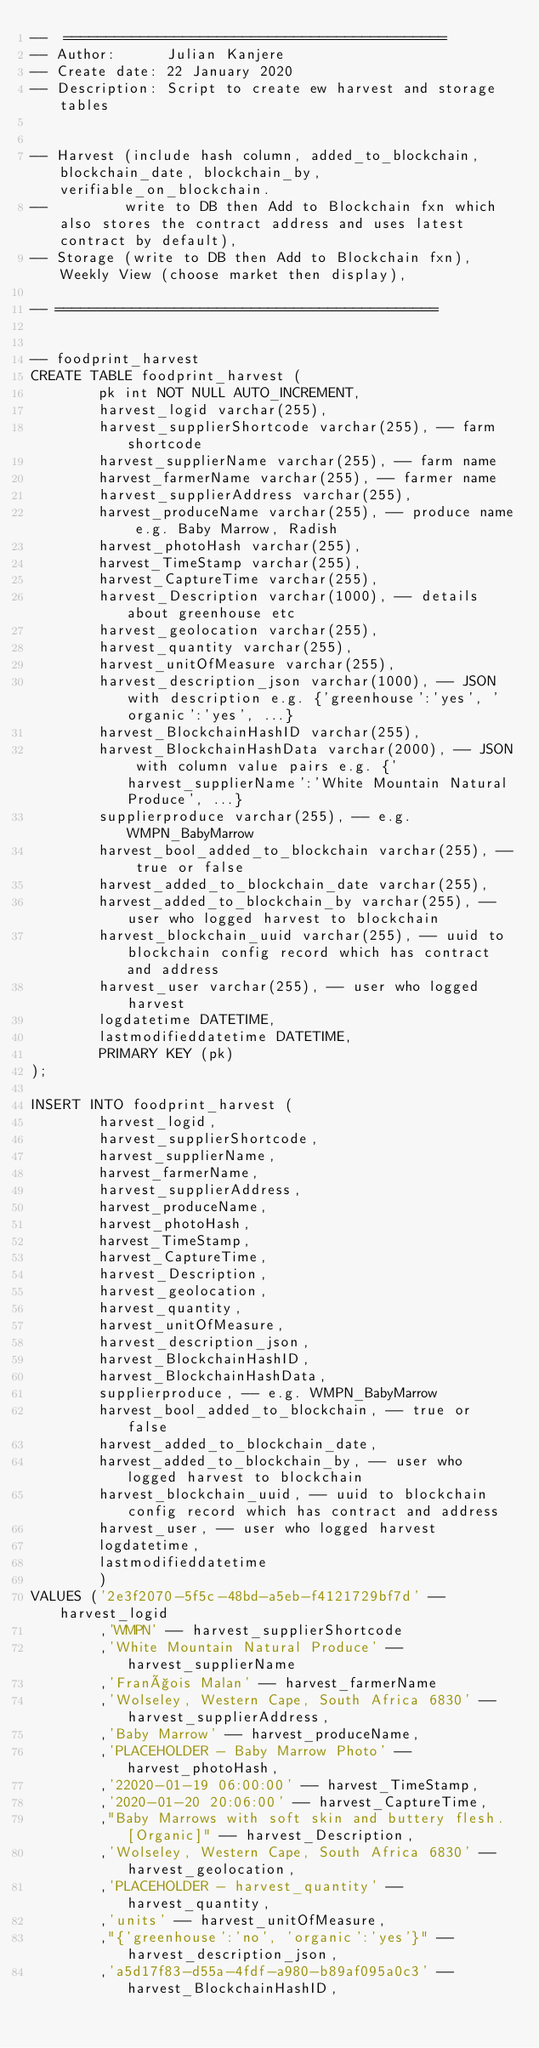<code> <loc_0><loc_0><loc_500><loc_500><_SQL_>--  =============================================
-- Author:      Julian Kanjere
-- Create date: 22 January 2020
-- Description: Script to create ew harvest and storage tables


-- Harvest (include hash column, added_to_blockchain, blockchain_date, blockchain_by, verifiable_on_blockchain.
--         write to DB then Add to Blockchain fxn which also stores the contract address and uses latest contract by default),
-- Storage (write to DB then Add to Blockchain fxn), Weekly View (choose market then display),

-- =============================================


-- foodprint_harvest
CREATE TABLE foodprint_harvest (
        pk int NOT NULL AUTO_INCREMENT,
        harvest_logid varchar(255),
        harvest_supplierShortcode varchar(255), -- farm shortcode
        harvest_supplierName varchar(255), -- farm name
        harvest_farmerName varchar(255), -- farmer name
        harvest_supplierAddress varchar(255),
        harvest_produceName varchar(255), -- produce name e.g. Baby Marrow, Radish
        harvest_photoHash varchar(255),
        harvest_TimeStamp varchar(255),
        harvest_CaptureTime varchar(255),
        harvest_Description varchar(1000), -- details about greenhouse etc
        harvest_geolocation varchar(255),
        harvest_quantity varchar(255),
        harvest_unitOfMeasure varchar(255),
        harvest_description_json varchar(1000), -- JSON with description e.g. {'greenhouse':'yes', 'organic':'yes', ...}
        harvest_BlockchainHashID varchar(255),
        harvest_BlockchainHashData varchar(2000), -- JSON with column value pairs e.g. {'harvest_supplierName':'White Mountain Natural Produce', ...}
        supplierproduce varchar(255), -- e.g. WMPN_BabyMarrow
        harvest_bool_added_to_blockchain varchar(255), -- true or false
        harvest_added_to_blockchain_date varchar(255), 
        harvest_added_to_blockchain_by varchar(255), -- user who logged harvest to blockchain
        harvest_blockchain_uuid varchar(255), -- uuid to blockchain config record which has contract and address
        harvest_user varchar(255), -- user who logged harvest
        logdatetime DATETIME,
        lastmodifieddatetime DATETIME,
        PRIMARY KEY (pk)
);

INSERT INTO foodprint_harvest (
        harvest_logid,
        harvest_supplierShortcode,
        harvest_supplierName, 
        harvest_farmerName,
        harvest_supplierAddress,
        harvest_produceName,
        harvest_photoHash,
        harvest_TimeStamp,
        harvest_CaptureTime,
        harvest_Description,
        harvest_geolocation,
        harvest_quantity,
        harvest_unitOfMeasure,
        harvest_description_json,
        harvest_BlockchainHashID,
        harvest_BlockchainHashData, 
        supplierproduce, -- e.g. WMPN_BabyMarrow
        harvest_bool_added_to_blockchain, -- true or false
        harvest_added_to_blockchain_date, 
        harvest_added_to_blockchain_by, -- user who logged harvest to blockchain
        harvest_blockchain_uuid, -- uuid to blockchain config record which has contract and address
        harvest_user, -- user who logged harvest
        logdatetime,
        lastmodifieddatetime
        )
VALUES ('2e3f2070-5f5c-48bd-a5eb-f4121729bf7d' -- harvest_logid
        ,'WMPN' -- harvest_supplierShortcode 
        ,'White Mountain Natural Produce' -- harvest_supplierName
        ,'François Malan' -- harvest_farmerName
        ,'Wolseley, Western Cape, South Africa 6830' -- harvest_supplierAddress,
        ,'Baby Marrow' -- harvest_produceName,
        ,'PLACEHOLDER - Baby Marrow Photo' -- harvest_photoHash,
        ,'22020-01-19 06:00:00' -- harvest_TimeStamp,
        ,'2020-01-20 20:06:00' -- harvest_CaptureTime,
        ,"Baby Marrows with soft skin and buttery flesh. [Organic]" -- harvest_Description,
        ,'Wolseley, Western Cape, South Africa 6830' -- harvest_geolocation,
        ,'PLACEHOLDER - harvest_quantity' -- harvest_quantity,
        ,'units' -- harvest_unitOfMeasure,
        ,"{'greenhouse':'no', 'organic':'yes'}" -- harvest_description_json,
        ,'a5d17f83-d55a-4fdf-a980-b89af095a0c3' -- harvest_BlockchainHashID,</code> 